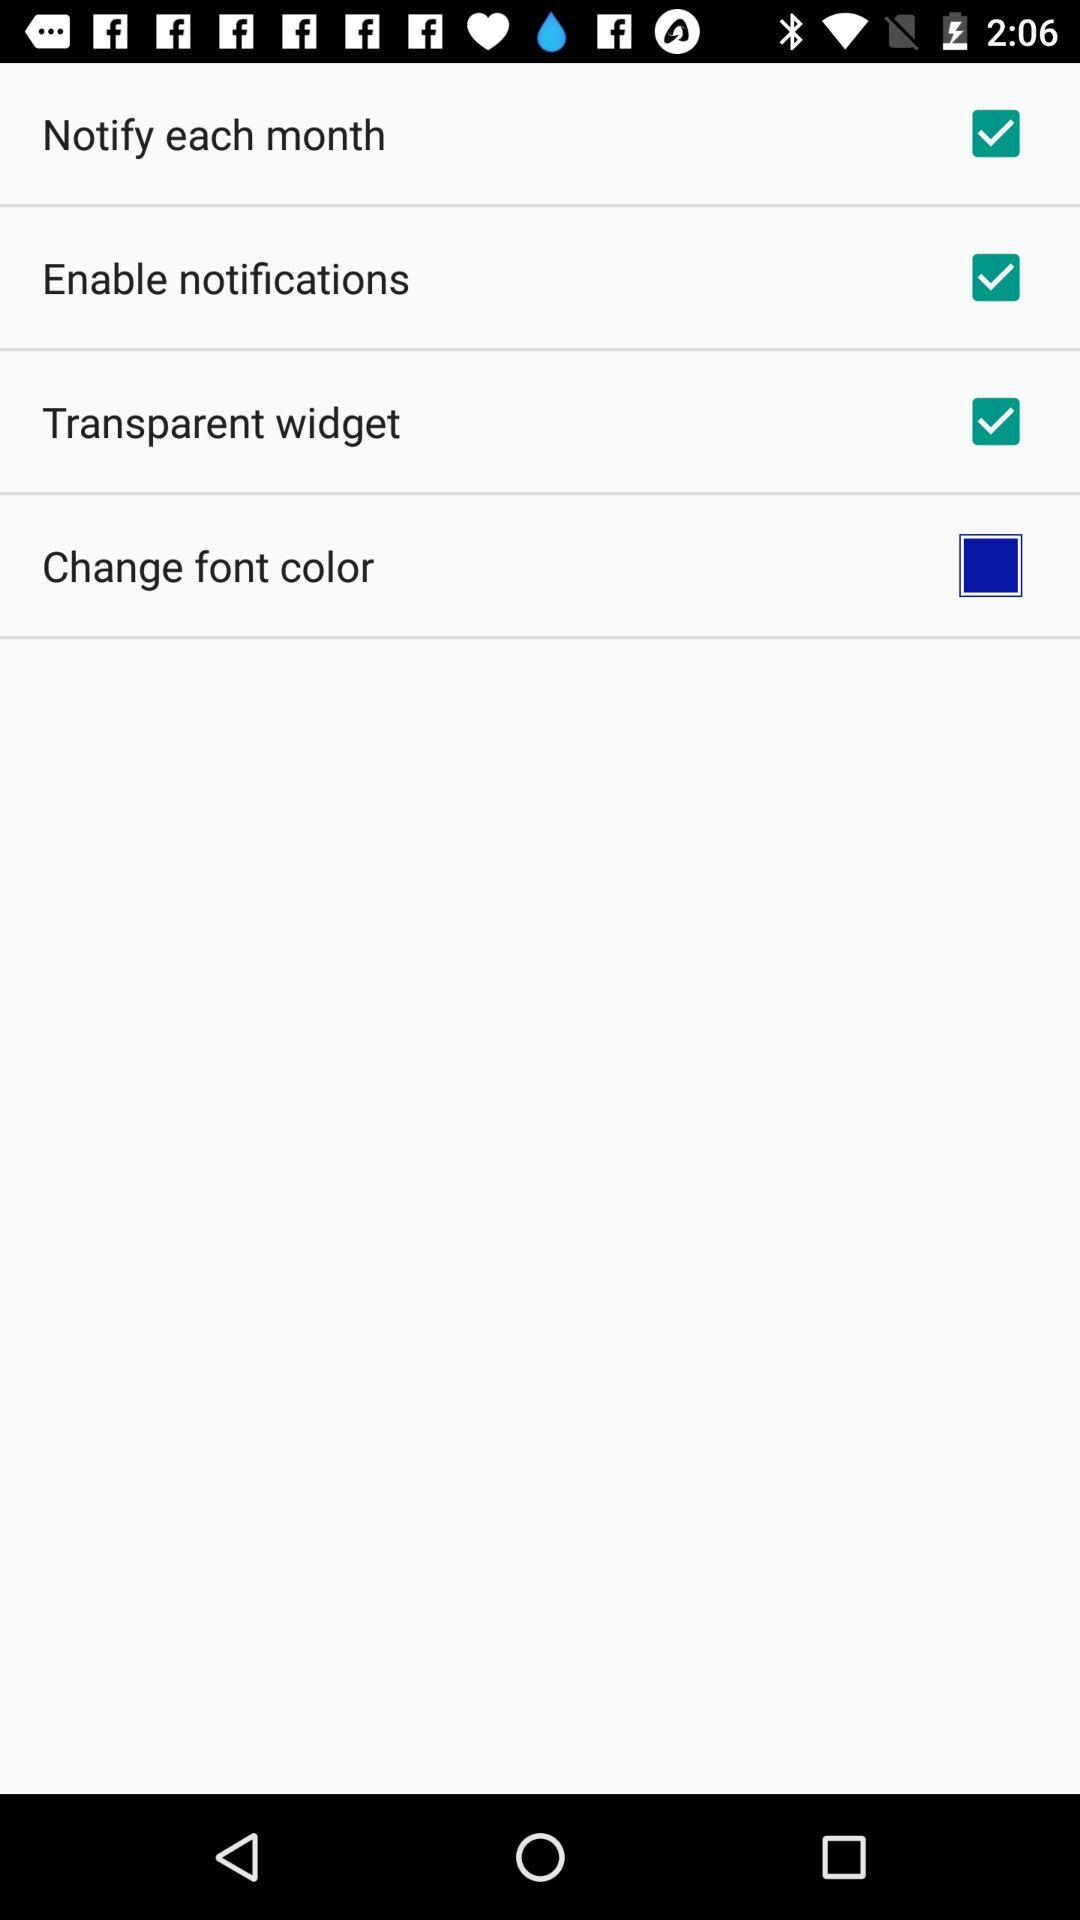What option is not selected? The option is "Change font color". 